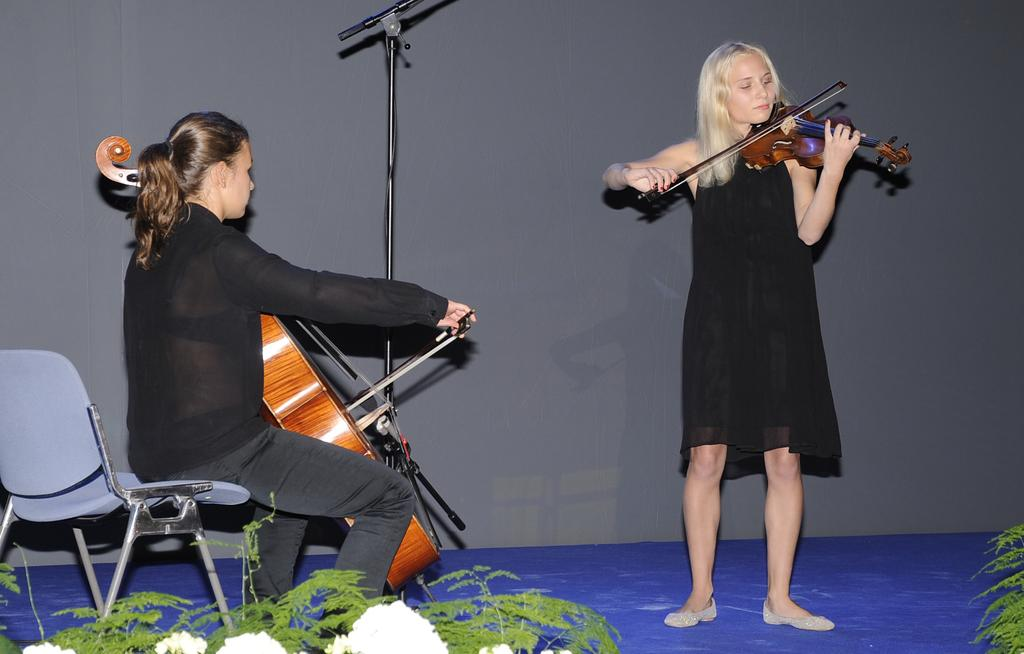How many women are in the image? There are two women in the image. What are the positions of the women in the image? One woman is sitting on a chair, and the other woman is standing. What are the women holding in the image? Both women are holding musical instruments. What type of quill is the woman using to play her instrument in the image? There is no quill present in the image; both women are holding musical instruments, but they are not using quills to play them. 